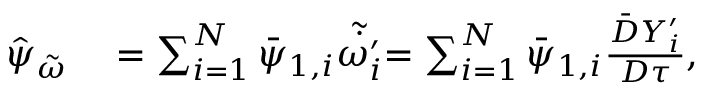<formula> <loc_0><loc_0><loc_500><loc_500>\begin{array} { r l } { \hat { \psi } _ { \tilde { \omega } } } & = \sum _ { i = 1 } ^ { N } \bar { \psi } _ { 1 , i } \tilde { \dot { \omega _ { i } ^ { \prime } } } { = \sum _ { i = 1 } ^ { N } \bar { \psi } _ { 1 , i } \frac { \bar { D } Y _ { i } ^ { \prime } } { D \tau } } , } \end{array}</formula> 